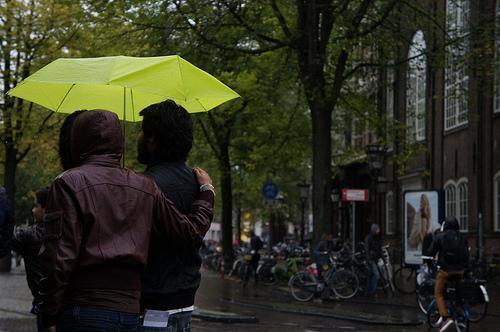How many people are under the umbrella?
Give a very brief answer. 2. 